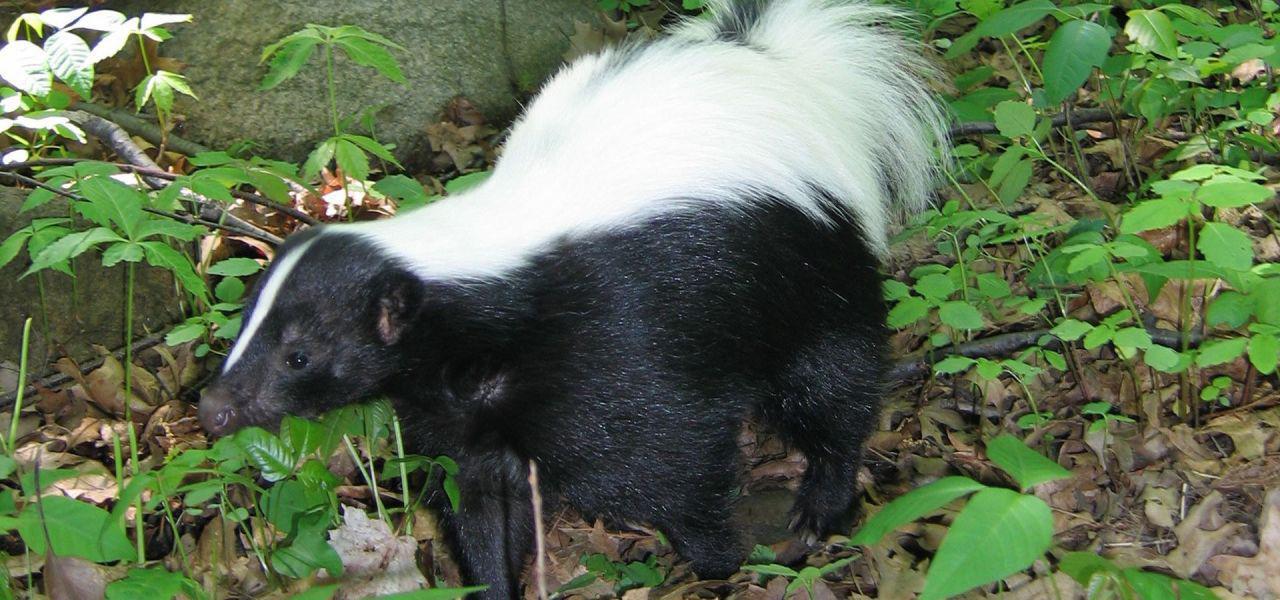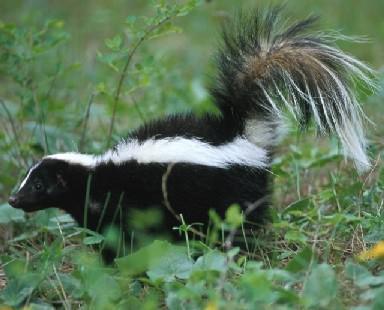The first image is the image on the left, the second image is the image on the right. Examine the images to the left and right. Is the description "The right image includes at least two somewhat forward-angled side-by-side skunks with their tails up." accurate? Answer yes or no. No. The first image is the image on the left, the second image is the image on the right. Assess this claim about the two images: "There are more than two skunks in total.". Correct or not? Answer yes or no. No. 